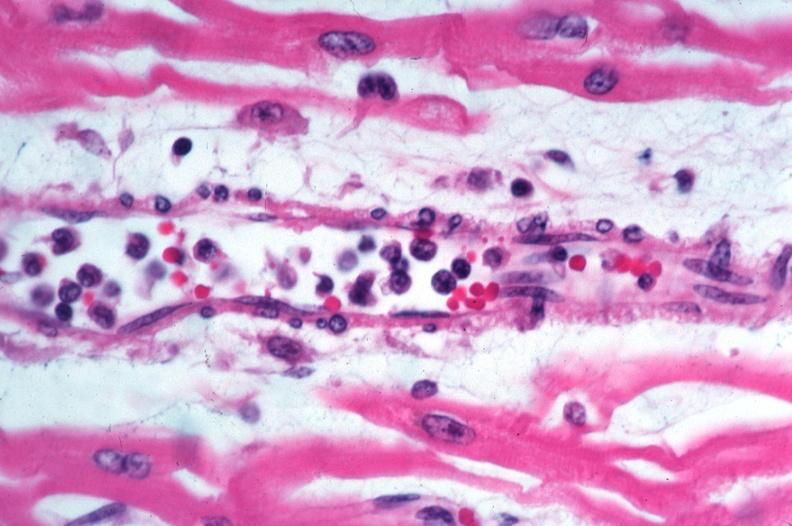does this image show skin?
Answer the question using a single word or phrase. Yes 